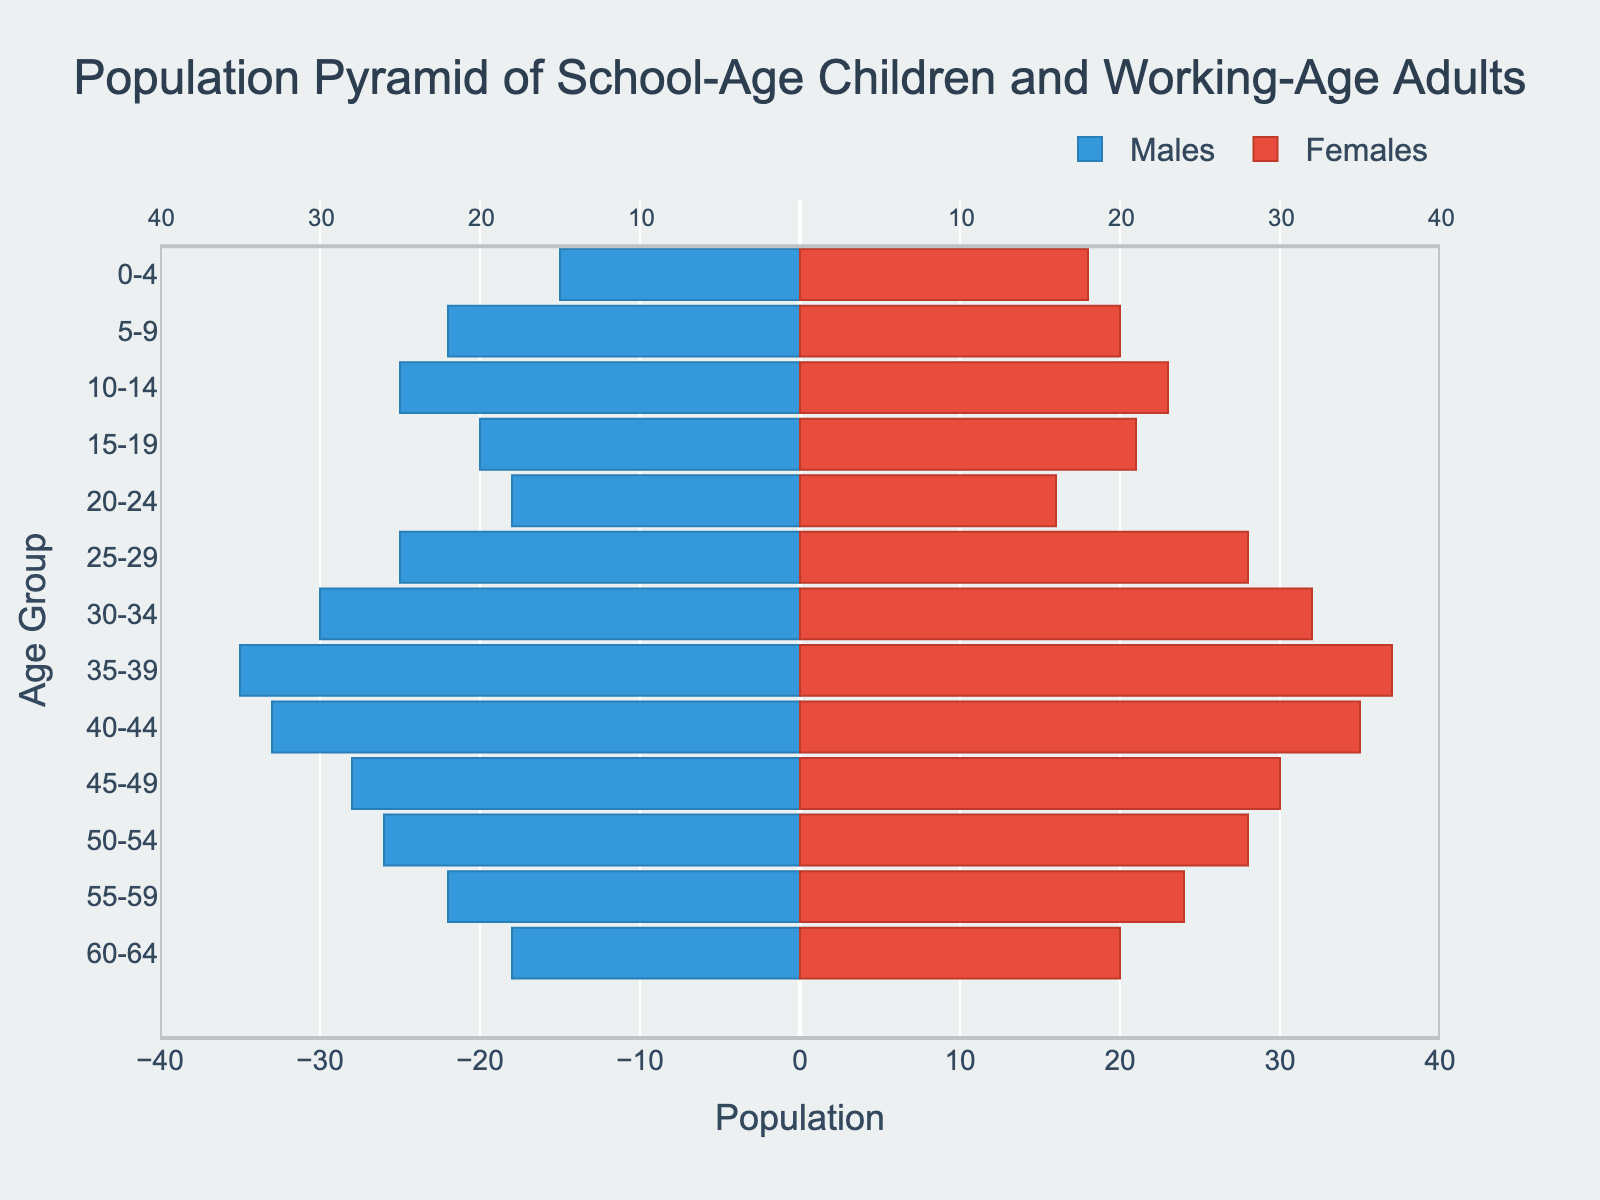What is the title of the figure? The title of the figure is prominently displayed at the top of the plot with larger font size and reads "Population Pyramid of School-Age Children and Working-Age Adults".
Answer: Population Pyramid of School-Age Children and Working-Age Adults Which group has the highest number of males? To find the group with the highest number of males, look at the left side of the pyramid and identify the longest bar. The "35-39" age group has the longest bar.
Answer: 35-39 age group What age group has an equal number of males and females? Look for age groups where the lengths of the bars on both sides are equal. For the "15-19" age group, the lengths of the male and female bars are closest to each other.
Answer: 15-19 age group What is the total number of males in the "10-14" and "15-19" age groups? Add the male population from the two age groups: 25 (10-14) + 20 (15-19) = 45.
Answer: 45 Which age group has more females than males, and by how many? Compare the bars of males and females for each age group and find where the female bar is longer. Then, calculate the difference. For "25-29," females are 28 and males are 25, so the difference is 28 - 25 = 3.
Answer: 25-29 age group, by 3 What is the total population of the "30-34" age group? Add the male and female populations in this age group: 30 (males) + 32 (females) = 62.
Answer: 62 How does the population differ between the youngest age group and the oldest age group? Compare the bars for the "0-4" and "60-64" age groups. "0-4" males are 15, females are 18; "60-64" males are 18, females are 20. The difference is calculated by comparing both males and females separately.
Answer: Youngest age group: Males 15, Females 18; Oldest age group: Males 18, Females 20 